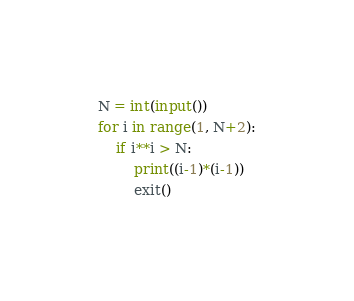Convert code to text. <code><loc_0><loc_0><loc_500><loc_500><_Python_>N = int(input())
for i in range(1, N+2):
    if i**i > N:
        print((i-1)*(i-1))
        exit()</code> 